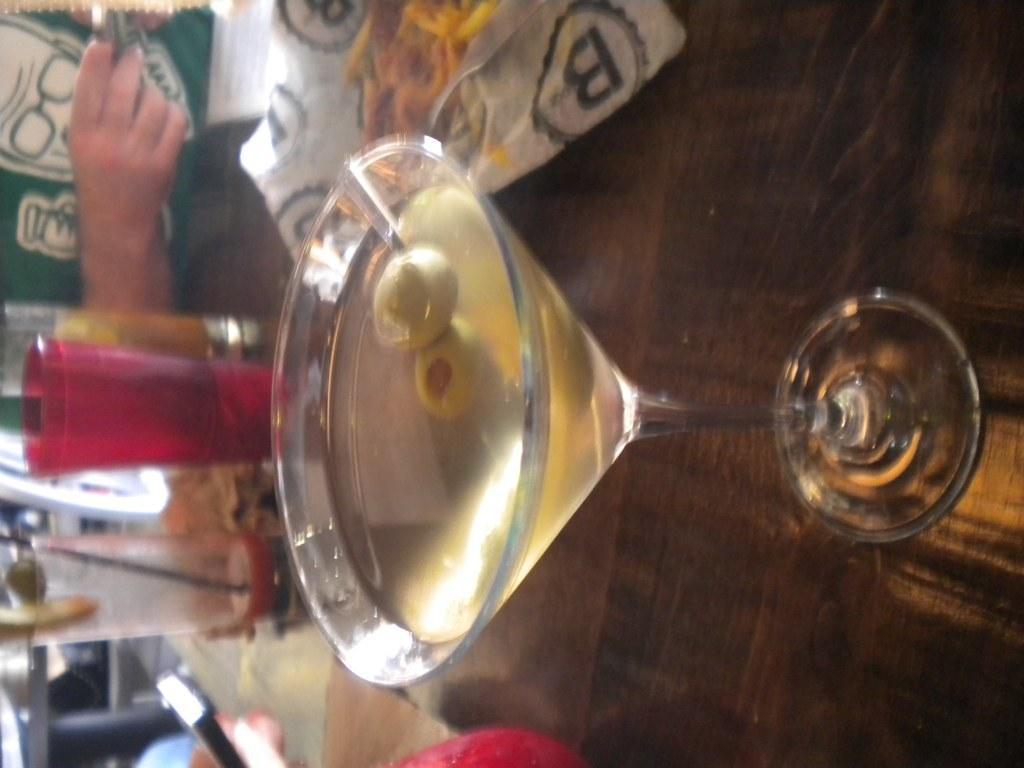How would you summarize this image in a sentence or two? There is a glass with drink on a surface. Also there is a packet and glasses on the surface. And there is a person. 